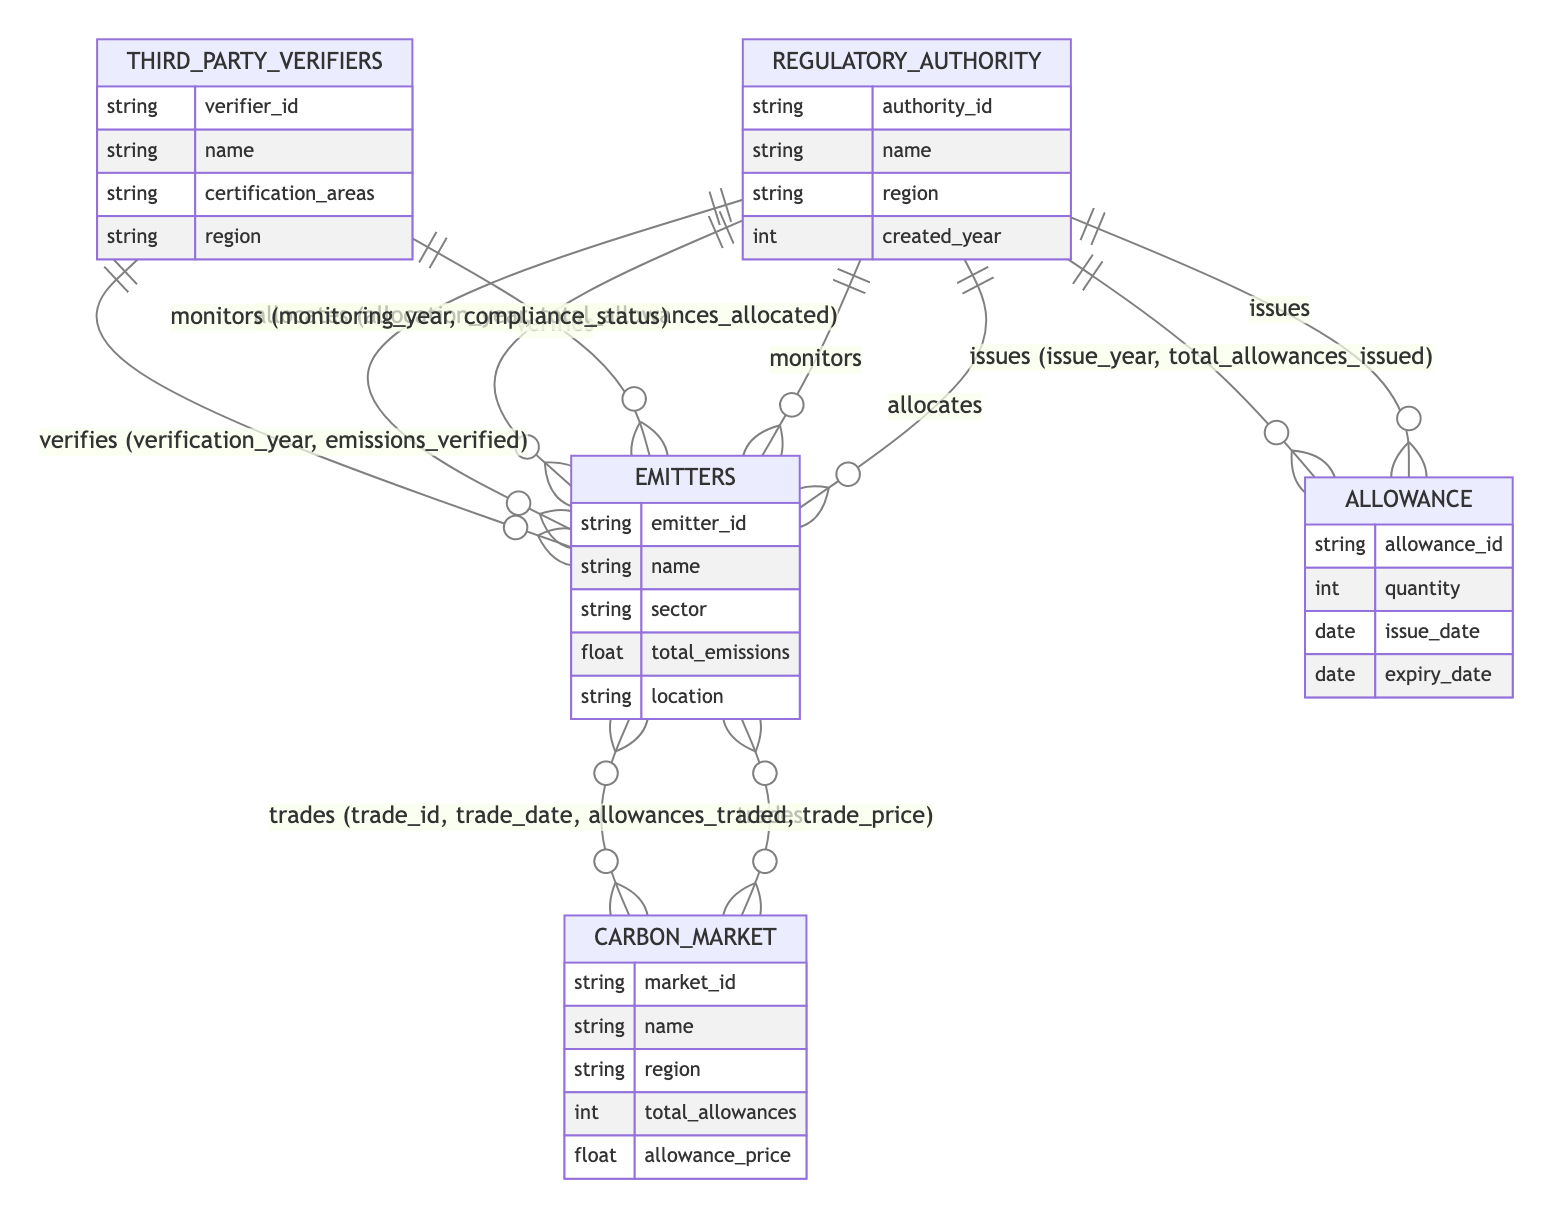What entity allocates allowances to emitters? The diagram shows that the Regulatory Authority is responsible for allocating allowances to Emitters through the "allocates" relationship.
Answer: Regulatory Authority How many entities are involved in the cap-and-trade system? The diagram lists five entities: Regulatory Authority, Emitters, Carbon Market, Allowance, and Third-Party Verifiers, making a total of five entities.
Answer: 5 What relationship connects Emitters to the Carbon Market? The Emitters are connected to the Carbon Market through the "trades" relationship, which facilitates trading of allowances between these two entities.
Answer: trades Which entity verifies the emissions of Emitters? The diagram indicates that Third-Party Verifiers are the entities that verify the emissions reported by Emitters.
Answer: Third-Party Verifiers What attributes are associated with the Allowance entity? The attributes associated with the Allowance entity include allowance_id, quantity, issue_date, and expiry_date, showing the properties of each allowance.
Answer: allowance_id, quantity, issue_date, expiry_date In what year does the Regulatory Authority issue allowances? The attribute "issue_year" within the "issues" relationship indicates the year when the Regulatory Authority issues allowances to emitters, as defined in the diagram.
Answer: issue_year What status is monitored by the Regulatory Authority? The Regulatory Authority monitors the compliance status of Emitters, as indicated in the "monitors" relationship.
Answer: compliance_status Which relationship involves the attributes trade_id and trade_date? The "trades" relationship between Emitters and the Carbon Market involves the attributes trade_id and trade_date to capture details of each trade transaction.
Answer: trades Which entity is responsible for monitoring emitters? The Regulatory Authority is responsible for monitoring Emitters, as shown by the "monitors" relationship in the diagram.
Answer: Regulatory Authority 